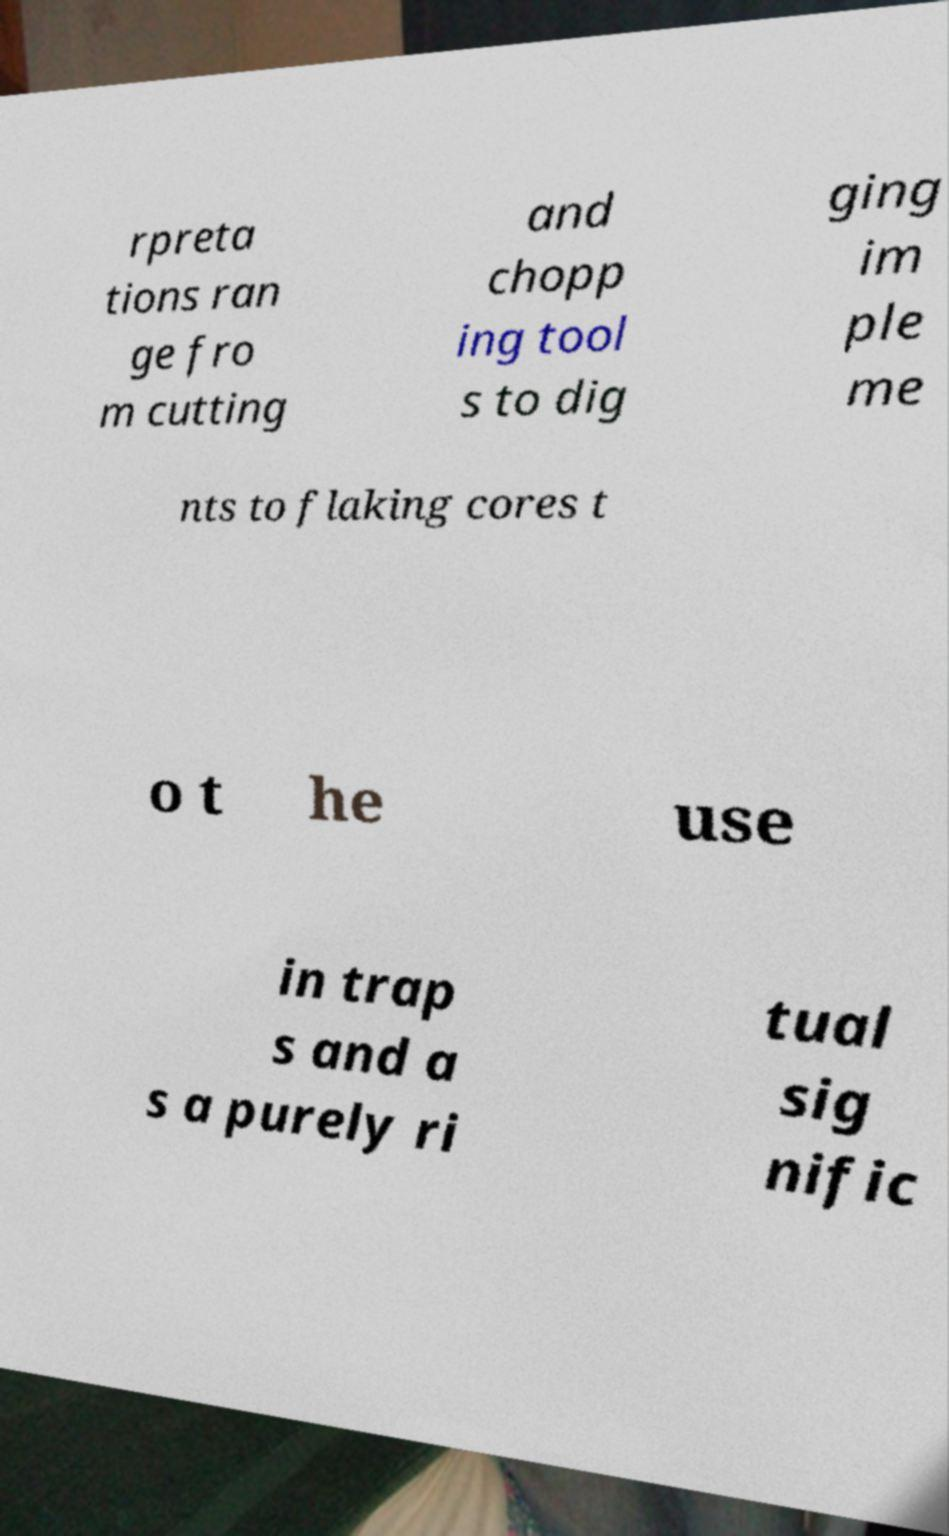Please read and relay the text visible in this image. What does it say? rpreta tions ran ge fro m cutting and chopp ing tool s to dig ging im ple me nts to flaking cores t o t he use in trap s and a s a purely ri tual sig nific 